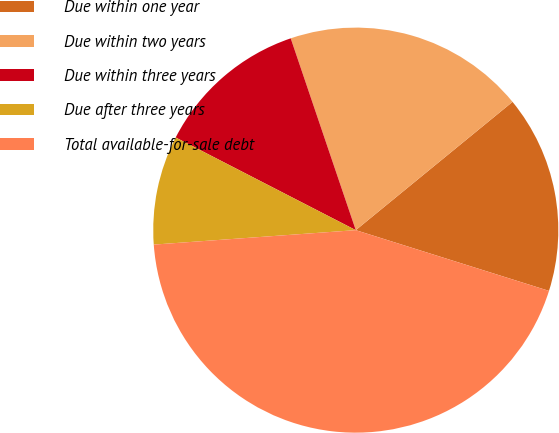Convert chart. <chart><loc_0><loc_0><loc_500><loc_500><pie_chart><fcel>Due within one year<fcel>Due within two years<fcel>Due within three years<fcel>Due after three years<fcel>Total available-for-sale debt<nl><fcel>15.76%<fcel>19.29%<fcel>12.23%<fcel>8.7%<fcel>44.01%<nl></chart> 